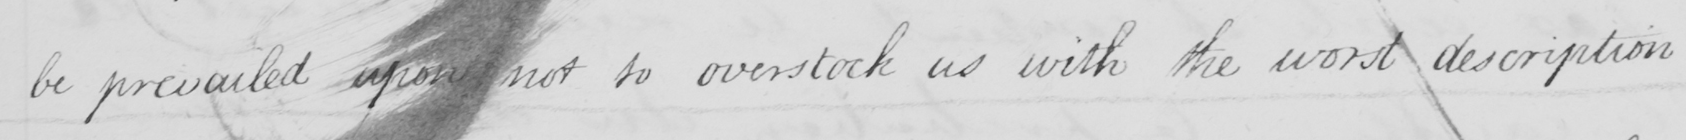Transcribe the text shown in this historical manuscript line. be prevailed upon not to overstock us with the worst description 